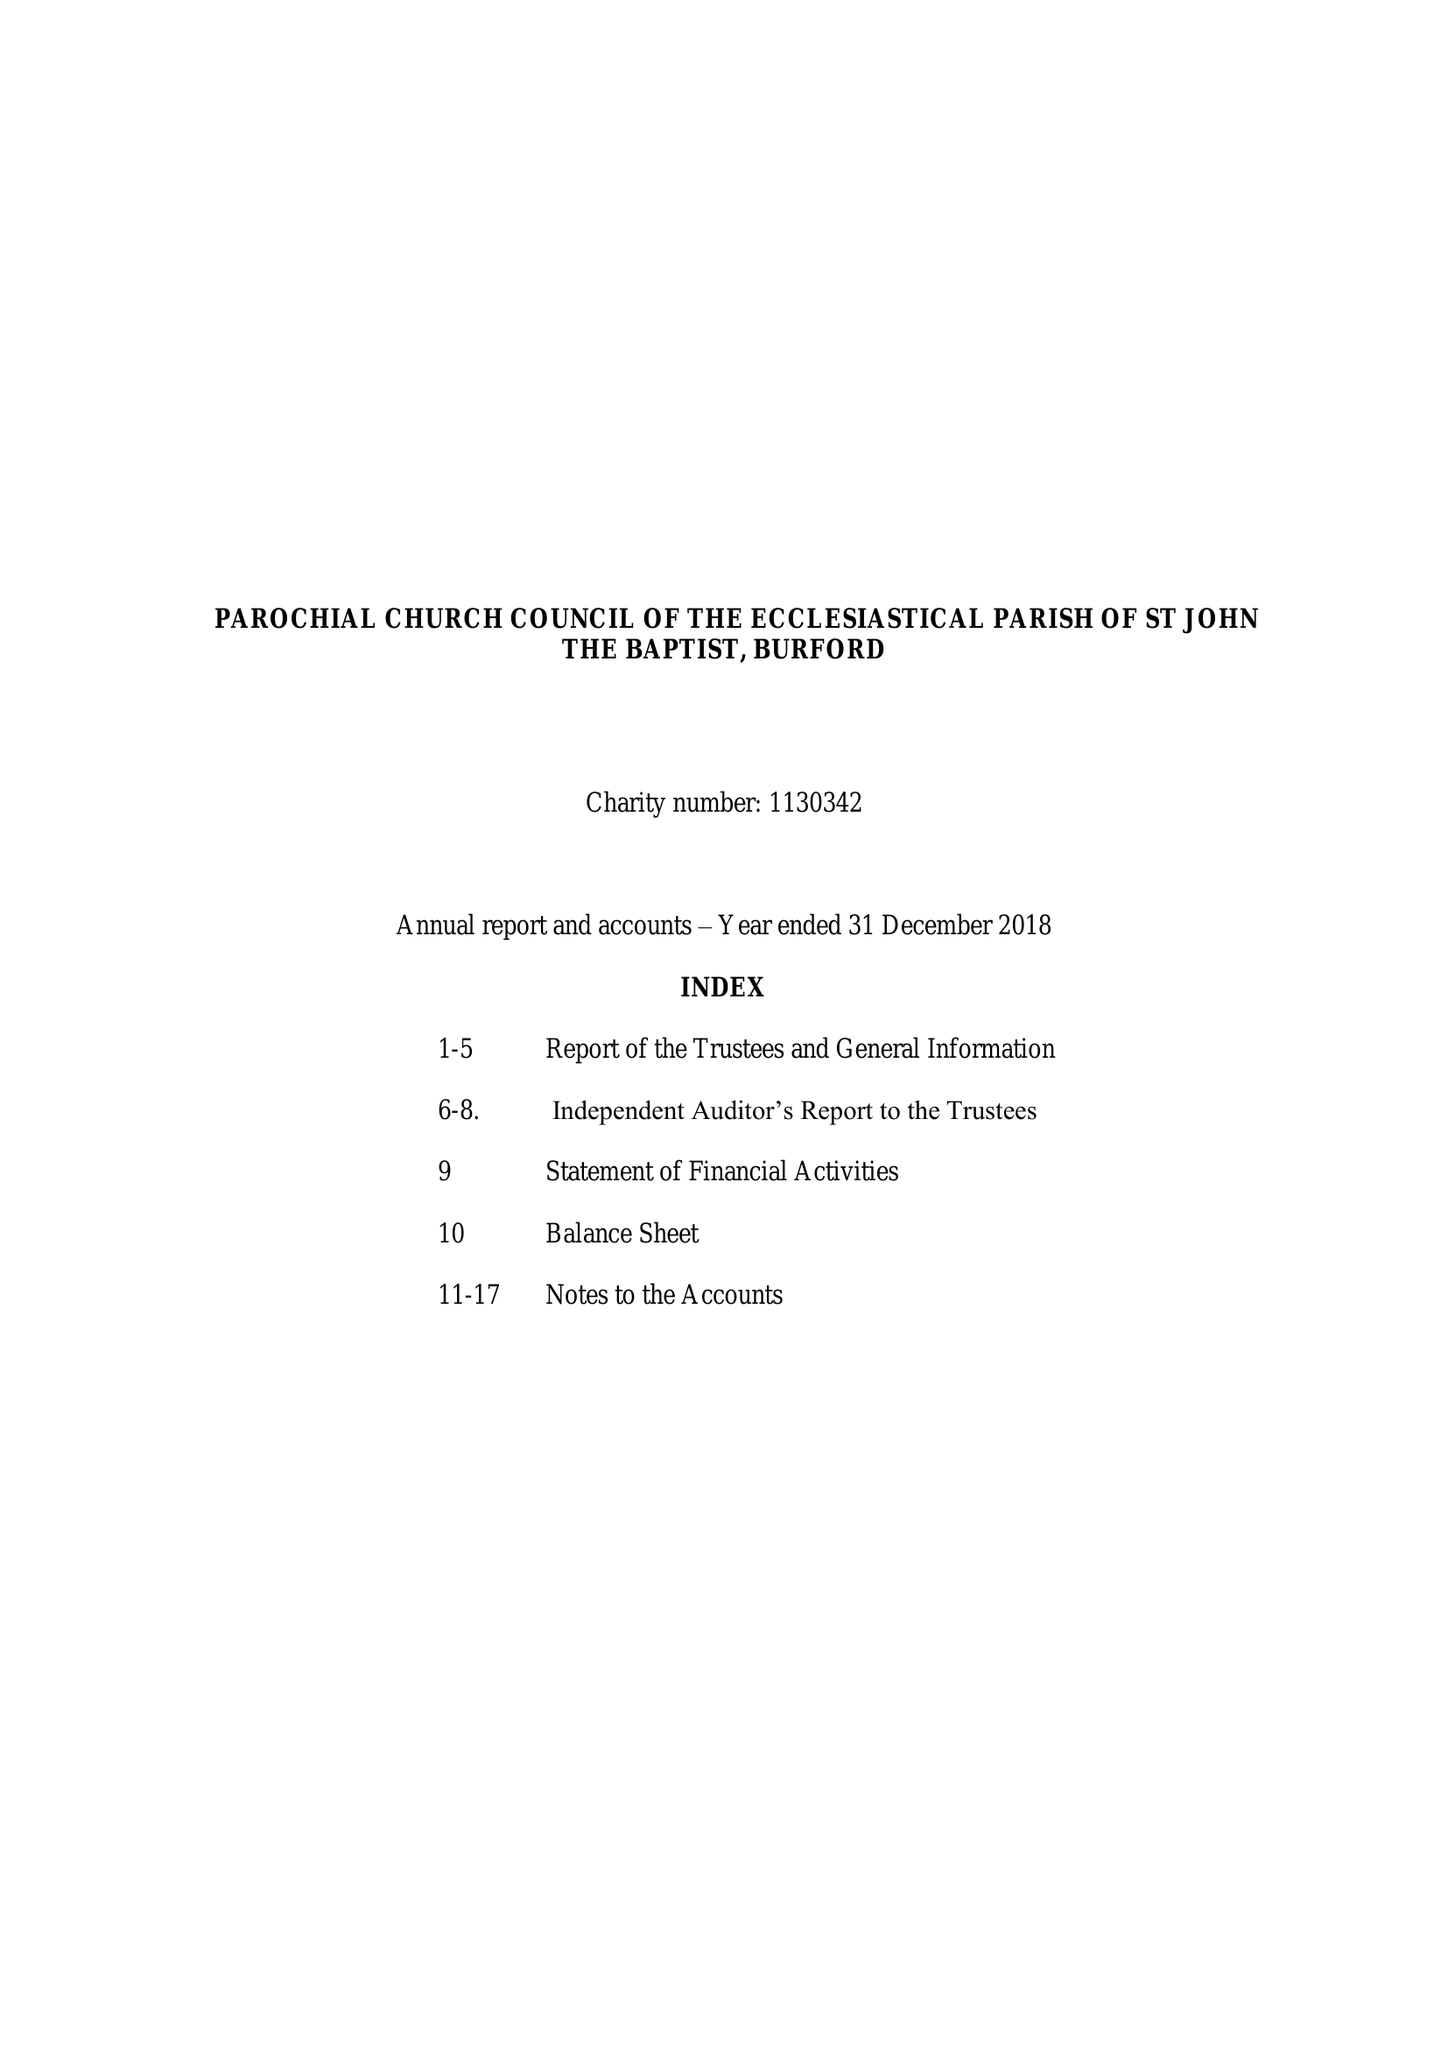What is the value for the charity_number?
Answer the question using a single word or phrase. 1130342 